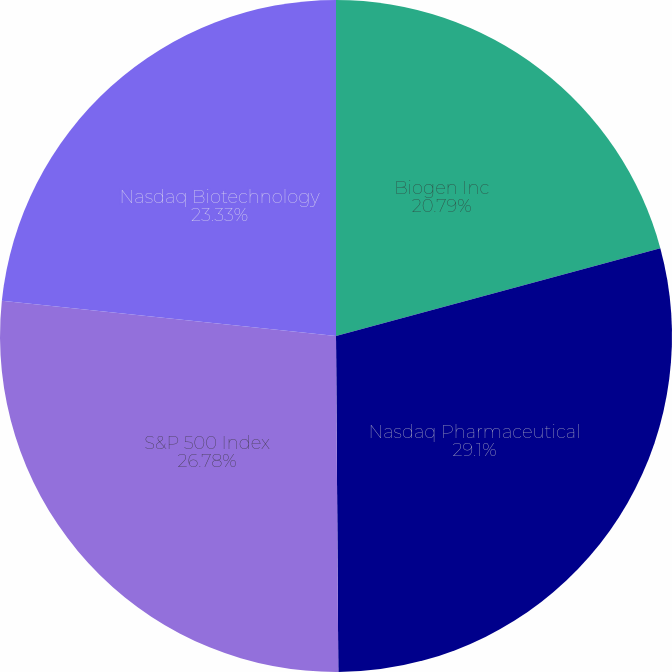Convert chart. <chart><loc_0><loc_0><loc_500><loc_500><pie_chart><fcel>Biogen Inc<fcel>Nasdaq Pharmaceutical<fcel>S&P 500 Index<fcel>Nasdaq Biotechnology<nl><fcel>20.79%<fcel>29.1%<fcel>26.78%<fcel>23.33%<nl></chart> 